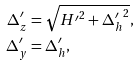Convert formula to latex. <formula><loc_0><loc_0><loc_500><loc_500>\Delta ^ { \prime } _ { z } & = \sqrt { { H ^ { \prime } } ^ { 2 } + { \Delta ^ { \prime } _ { h } } ^ { 2 } } , \\ \Delta ^ { \prime } _ { y } & = \Delta ^ { \prime } _ { h } ,</formula> 